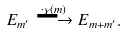Convert formula to latex. <formula><loc_0><loc_0><loc_500><loc_500>E _ { m ^ { \prime } } \overset { \cdot \chi ( m ) } \longrightarrow E _ { m + m ^ { \prime } } .</formula> 